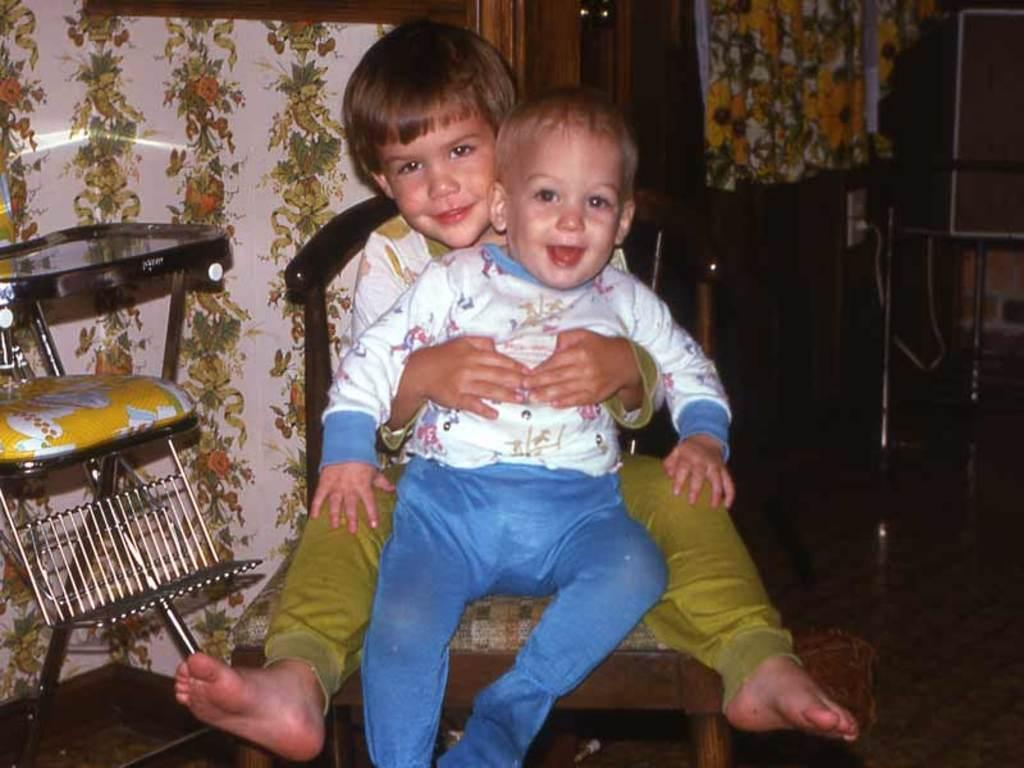How many kids are present in the image? There are two kids in the image. What are the kids doing in the image? The kids are sitting on a chair. What other object can be seen in the image? There is an iron stand in the image. What type of curtain is hanging from the iron stand in the image? There is no curtain present in the image; only the kids and the iron stand are visible. Can you see any smoke coming from the iron stand in the image? There is no smoke visible in the image, and the iron stand does not appear to be in use. 